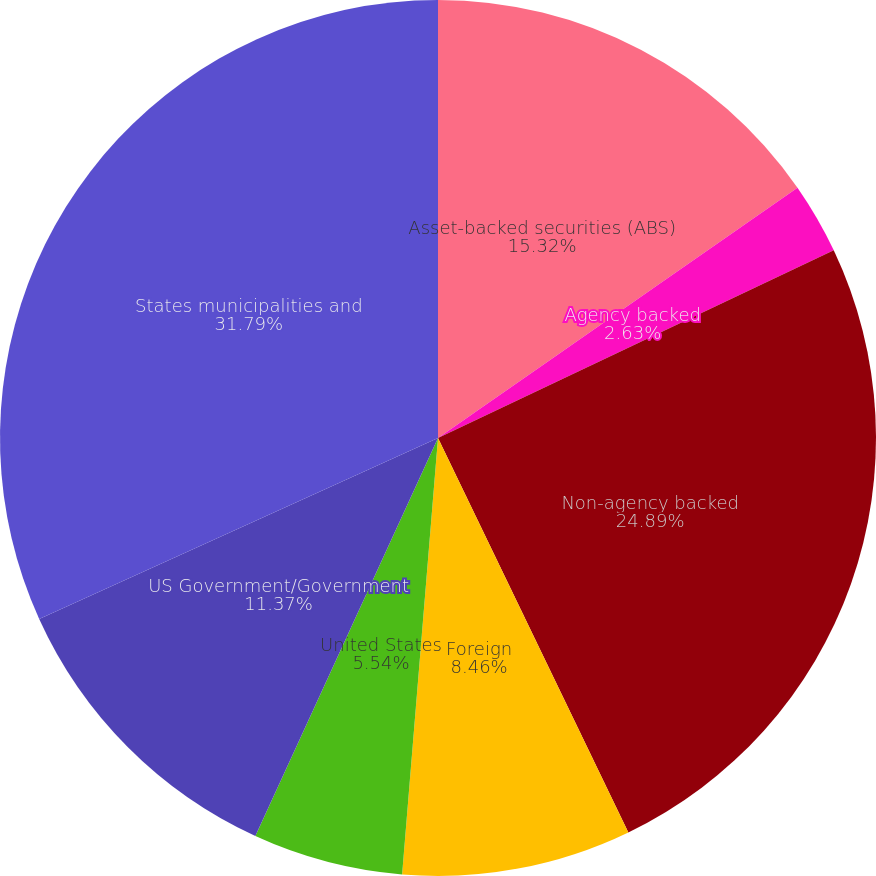Convert chart. <chart><loc_0><loc_0><loc_500><loc_500><pie_chart><fcel>Asset-backed securities (ABS)<fcel>Agency backed<fcel>Non-agency backed<fcel>Foreign<fcel>United States<fcel>US Government/Government<fcel>States municipalities and<nl><fcel>15.32%<fcel>2.63%<fcel>24.89%<fcel>8.46%<fcel>5.54%<fcel>11.37%<fcel>31.78%<nl></chart> 